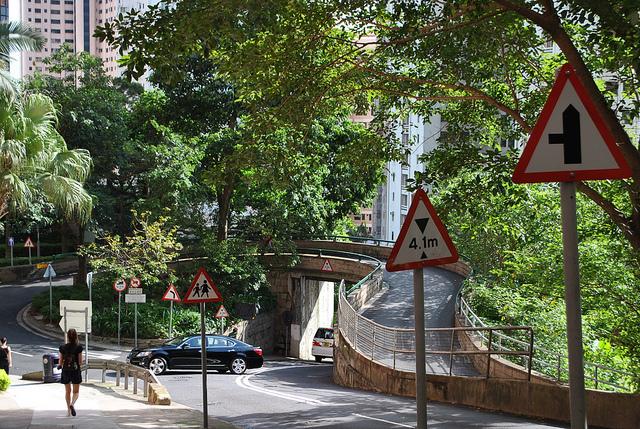Is this picture taken in the US?
Keep it brief. No. Where is the palm tree?
Quick response, please. Left. What color is the border on the signs?
Write a very short answer. Red. 